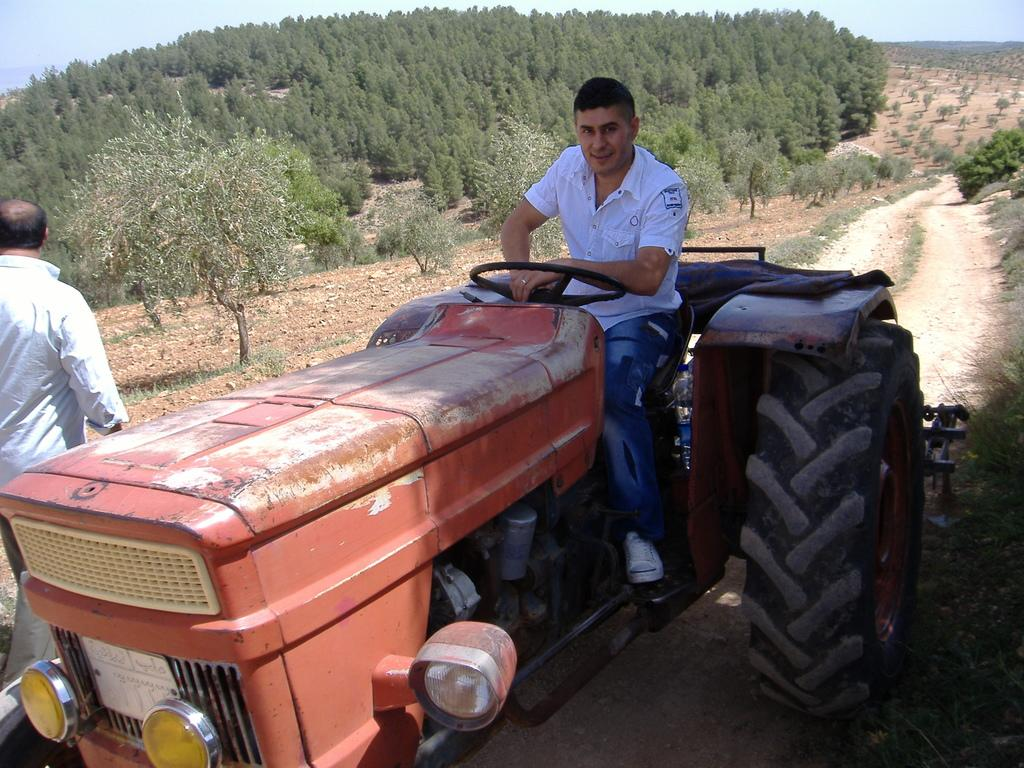What is the man in the image doing? There is a man sitting on a tractor, and another man is walking beside the tractor. What can be seen in the image besides the tractor and the men? There is grass visible in the image. What is visible in the background of the image? There are trees and the sky visible in the background of the image. What type of game is being played in the image? There is no game being played in the image; it features a man sitting on a tractor and another man walking beside it. Can you see any roses in the image? There are no roses present in the image. 